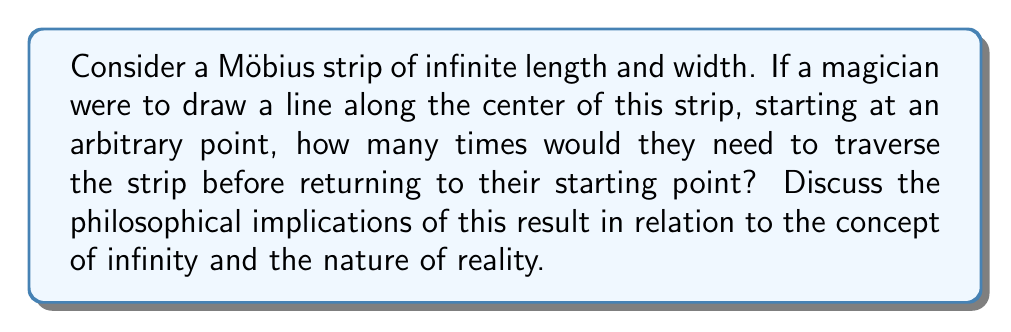Can you answer this question? To understand this problem, let's break it down step-by-step:

1) A Möbius strip is a topological object with only one side and one edge. It can be created by taking a long rectangular strip and giving it a half-twist before joining the ends.

2) In this case, we're considering a Möbius strip of infinite length and width. This is a theoretical construct that extends the properties of a finite Möbius strip to an infinite scale.

3) When drawing a line along the center of a finite Möbius strip, one would need to go around the strip twice to return to the starting point. This is because the Möbius strip has a "twist" that effectively doubles its apparent length when traversing its center.

4) However, in the case of an infinite Möbius strip, the concept of "returning to the starting point" becomes problematic. In a truly infinite strip, there is no "end" to reach, and thus no way to complete a circuit.

5) Mathematically, we can express this as:

   $$ \lim_{n \to \infty} \frac{2n}{n} = 2 $$

   Where $n$ represents the length of the strip. As $n$ approaches infinity, the ratio of the distance needed to travel (2n) to the length of the strip (n) approaches 2.

6) Philosophically, this presents several intriguing implications:

   a) The concept of "completion" or "return" becomes meaningless in the face of true infinity.
   b) It challenges our understanding of space and boundaries.
   c) It illustrates how mathematical abstractions can lead to paradoxical scenarios that defy intuition.

7) From the perspective of a magician exploring the deeper meaning behind illusions, this problem illustrates how our perception of reality can be limited by our finite experiences. Just as a magician creates illusions that seem to defy reality, the infinite Möbius strip creates a scenario that defies our usual understanding of space and completion.
Answer: In a Möbius strip of infinite length and width, a magician drawing a line along its center would never return to their starting point. The concept of "returning" becomes meaningless in the context of infinity. Philosophically, this illustrates the limitations of finite perception when confronted with infinite concepts, challenging our understanding of reality and completion. 